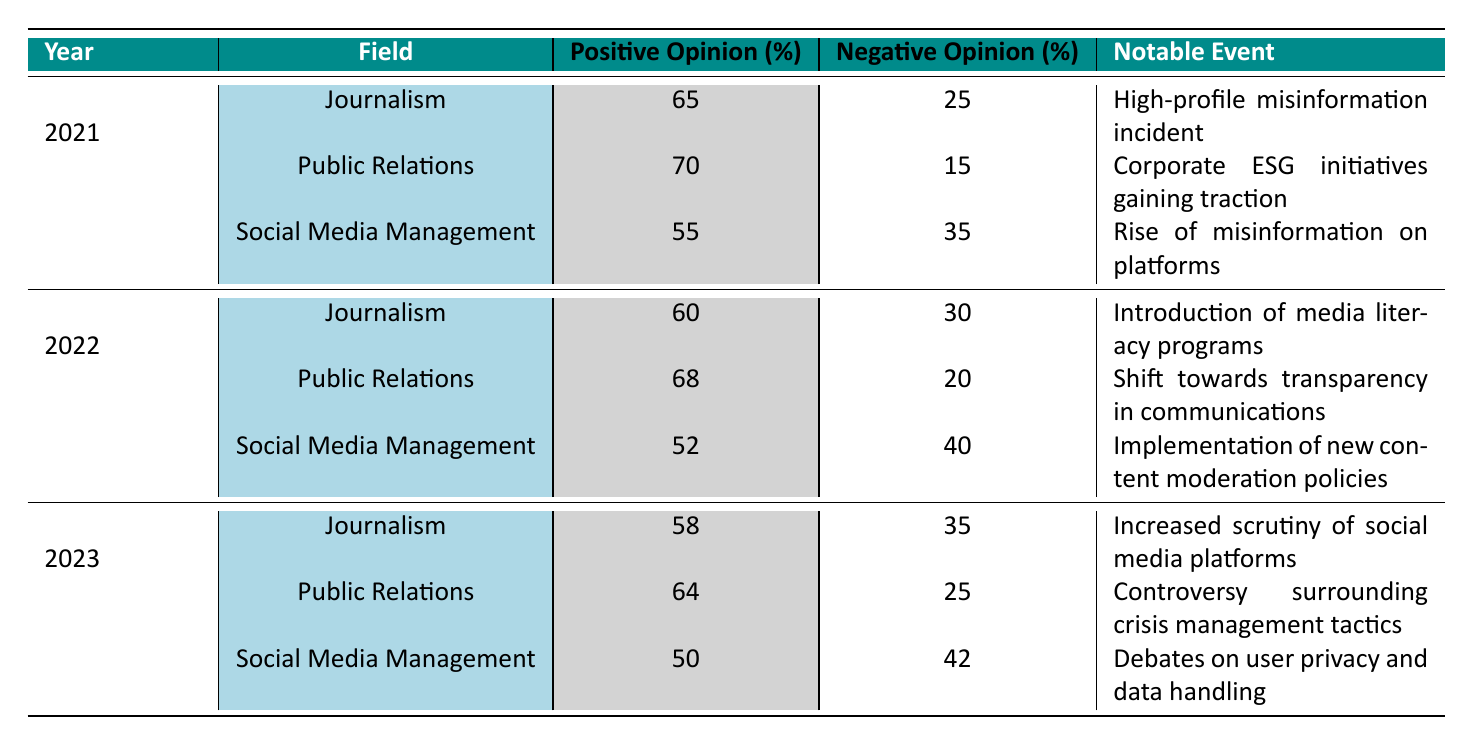What percentage of positive opinion was recorded for Journalism in 2022? The table indicates that for Journalism in 2022, the positive opinion percentage is noted as 60. This can be found directly under the corresponding column for that year and field.
Answer: 60 What is the notable event associated with Public Relations in 2023? The table lists the notable event linked to Public Relations in 2023 as "Controversy surrounding crisis management tactics." This specific information can be extracted directly from the table.
Answer: Controversy surrounding crisis management tactics Calculate the difference in positive opinion percentage for Social Media Management between 2021 and 2023. The positive opinion for Social Media Management in 2021 is 55, and in 2023 it is 50. To find the difference, subtract the 2023 percentage from the 2021 percentage: 55 - 50 = 5.
Answer: 5 Did the negative opinion percentage for Journalism increase from 2021 to 2023? Looking at the data, the negative opinion for Journalism in 2021 is 25%, and for 2023, it is 35%. Since 35% is greater than 25%, it confirms that the negative opinion percentage has indeed increased.
Answer: Yes What was the average positive opinion percentage across all fields in 2022? For 2022, the positive opinion percentages are 60 (Journalism), 68 (Public Relations), and 52 (Social Media Management). To calculate the average, sum these values: 60 + 68 + 52 = 180. Then divide by the number of fields (3): 180 / 3 = 60.
Answer: 60 Was there a notable event concerning misinformation for Social Media Management during 2021? Yes, the table indicates that the notable event for Social Media Management in 2021 was the "Rise of misinformation on platforms," confirming the presence of such an event.
Answer: Yes Which field had the highest percentage of positive opinion in 2021? In 2021, the positive opinions recorded were 65% for Journalism, 70% for Public Relations, and 55% for Social Media Management. The highest among these values is 70%, which belongs to Public Relations.
Answer: Public Relations What trend can be observed in the neutral opinion percentages for Social Media Management from 2021 to 2023? The neutral opinion percentages for Social Media Management are 10% in 2021, 8% in 2022, and 8% in 2023. This shows a decrease from 2021 to 2022 and remains the same in 2023, indicating a decline in neutral sentiments toward the field.
Answer: Decrease What was the percentage of negative opinion for Public Relations in 2022? The negative opinion percentage for Public Relations in 2022 is listed as 20%. This can be directly referenced from the respective year and field in the table.
Answer: 20 